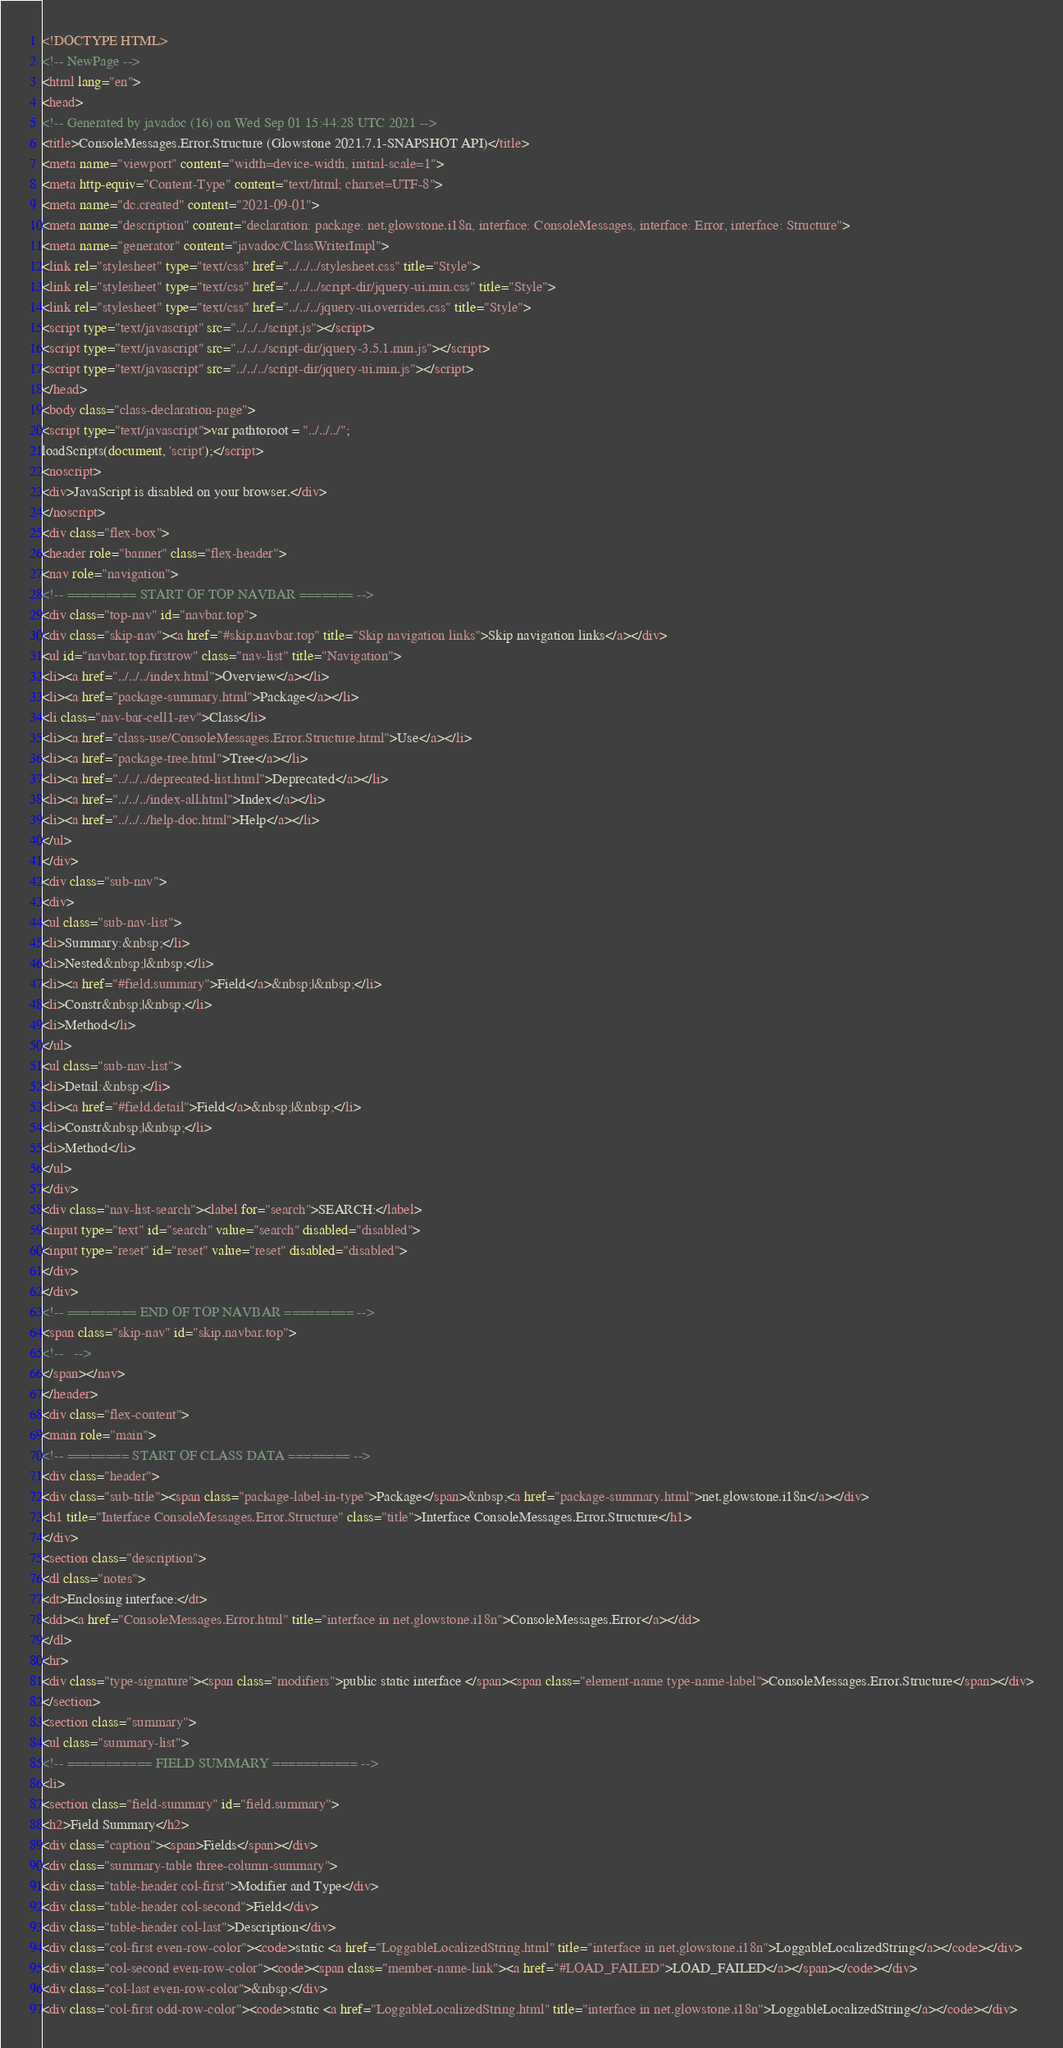Convert code to text. <code><loc_0><loc_0><loc_500><loc_500><_HTML_><!DOCTYPE HTML>
<!-- NewPage -->
<html lang="en">
<head>
<!-- Generated by javadoc (16) on Wed Sep 01 15:44:28 UTC 2021 -->
<title>ConsoleMessages.Error.Structure (Glowstone 2021.7.1-SNAPSHOT API)</title>
<meta name="viewport" content="width=device-width, initial-scale=1">
<meta http-equiv="Content-Type" content="text/html; charset=UTF-8">
<meta name="dc.created" content="2021-09-01">
<meta name="description" content="declaration: package: net.glowstone.i18n, interface: ConsoleMessages, interface: Error, interface: Structure">
<meta name="generator" content="javadoc/ClassWriterImpl">
<link rel="stylesheet" type="text/css" href="../../../stylesheet.css" title="Style">
<link rel="stylesheet" type="text/css" href="../../../script-dir/jquery-ui.min.css" title="Style">
<link rel="stylesheet" type="text/css" href="../../../jquery-ui.overrides.css" title="Style">
<script type="text/javascript" src="../../../script.js"></script>
<script type="text/javascript" src="../../../script-dir/jquery-3.5.1.min.js"></script>
<script type="text/javascript" src="../../../script-dir/jquery-ui.min.js"></script>
</head>
<body class="class-declaration-page">
<script type="text/javascript">var pathtoroot = "../../../";
loadScripts(document, 'script');</script>
<noscript>
<div>JavaScript is disabled on your browser.</div>
</noscript>
<div class="flex-box">
<header role="banner" class="flex-header">
<nav role="navigation">
<!-- ========= START OF TOP NAVBAR ======= -->
<div class="top-nav" id="navbar.top">
<div class="skip-nav"><a href="#skip.navbar.top" title="Skip navigation links">Skip navigation links</a></div>
<ul id="navbar.top.firstrow" class="nav-list" title="Navigation">
<li><a href="../../../index.html">Overview</a></li>
<li><a href="package-summary.html">Package</a></li>
<li class="nav-bar-cell1-rev">Class</li>
<li><a href="class-use/ConsoleMessages.Error.Structure.html">Use</a></li>
<li><a href="package-tree.html">Tree</a></li>
<li><a href="../../../deprecated-list.html">Deprecated</a></li>
<li><a href="../../../index-all.html">Index</a></li>
<li><a href="../../../help-doc.html">Help</a></li>
</ul>
</div>
<div class="sub-nav">
<div>
<ul class="sub-nav-list">
<li>Summary:&nbsp;</li>
<li>Nested&nbsp;|&nbsp;</li>
<li><a href="#field.summary">Field</a>&nbsp;|&nbsp;</li>
<li>Constr&nbsp;|&nbsp;</li>
<li>Method</li>
</ul>
<ul class="sub-nav-list">
<li>Detail:&nbsp;</li>
<li><a href="#field.detail">Field</a>&nbsp;|&nbsp;</li>
<li>Constr&nbsp;|&nbsp;</li>
<li>Method</li>
</ul>
</div>
<div class="nav-list-search"><label for="search">SEARCH:</label>
<input type="text" id="search" value="search" disabled="disabled">
<input type="reset" id="reset" value="reset" disabled="disabled">
</div>
</div>
<!-- ========= END OF TOP NAVBAR ========= -->
<span class="skip-nav" id="skip.navbar.top">
<!--   -->
</span></nav>
</header>
<div class="flex-content">
<main role="main">
<!-- ======== START OF CLASS DATA ======== -->
<div class="header">
<div class="sub-title"><span class="package-label-in-type">Package</span>&nbsp;<a href="package-summary.html">net.glowstone.i18n</a></div>
<h1 title="Interface ConsoleMessages.Error.Structure" class="title">Interface ConsoleMessages.Error.Structure</h1>
</div>
<section class="description">
<dl class="notes">
<dt>Enclosing interface:</dt>
<dd><a href="ConsoleMessages.Error.html" title="interface in net.glowstone.i18n">ConsoleMessages.Error</a></dd>
</dl>
<hr>
<div class="type-signature"><span class="modifiers">public static interface </span><span class="element-name type-name-label">ConsoleMessages.Error.Structure</span></div>
</section>
<section class="summary">
<ul class="summary-list">
<!-- =========== FIELD SUMMARY =========== -->
<li>
<section class="field-summary" id="field.summary">
<h2>Field Summary</h2>
<div class="caption"><span>Fields</span></div>
<div class="summary-table three-column-summary">
<div class="table-header col-first">Modifier and Type</div>
<div class="table-header col-second">Field</div>
<div class="table-header col-last">Description</div>
<div class="col-first even-row-color"><code>static <a href="LoggableLocalizedString.html" title="interface in net.glowstone.i18n">LoggableLocalizedString</a></code></div>
<div class="col-second even-row-color"><code><span class="member-name-link"><a href="#LOAD_FAILED">LOAD_FAILED</a></span></code></div>
<div class="col-last even-row-color">&nbsp;</div>
<div class="col-first odd-row-color"><code>static <a href="LoggableLocalizedString.html" title="interface in net.glowstone.i18n">LoggableLocalizedString</a></code></div></code> 